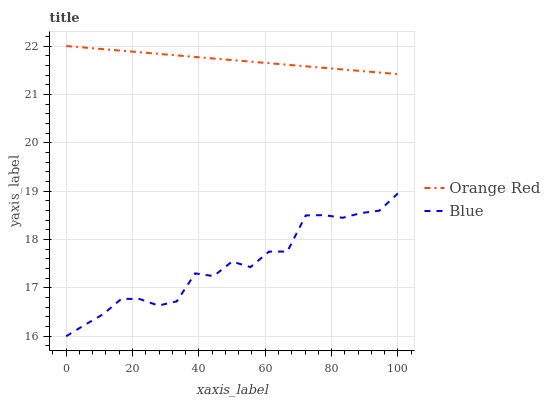Does Blue have the minimum area under the curve?
Answer yes or no. Yes. Does Orange Red have the maximum area under the curve?
Answer yes or no. Yes. Does Orange Red have the minimum area under the curve?
Answer yes or no. No. Is Orange Red the smoothest?
Answer yes or no. Yes. Is Blue the roughest?
Answer yes or no. Yes. Is Orange Red the roughest?
Answer yes or no. No. Does Blue have the lowest value?
Answer yes or no. Yes. Does Orange Red have the lowest value?
Answer yes or no. No. Does Orange Red have the highest value?
Answer yes or no. Yes. Is Blue less than Orange Red?
Answer yes or no. Yes. Is Orange Red greater than Blue?
Answer yes or no. Yes. Does Blue intersect Orange Red?
Answer yes or no. No. 